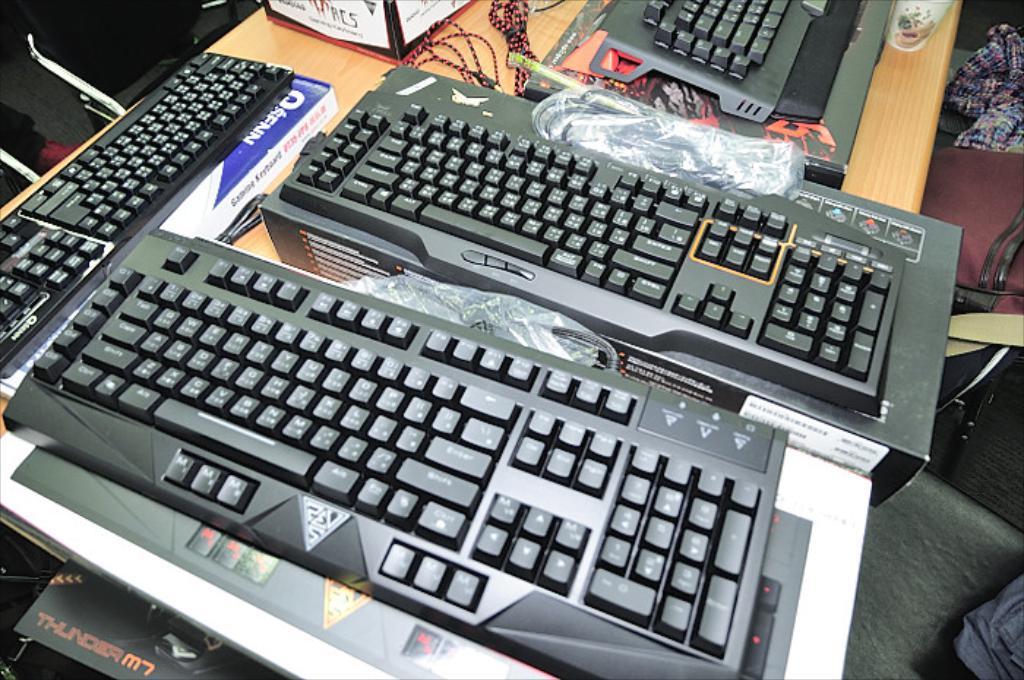What is the brand name in the lower left corner?
Provide a succinct answer. Thunder m7. 